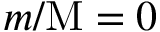<formula> <loc_0><loc_0><loc_500><loc_500>m / M = 0</formula> 